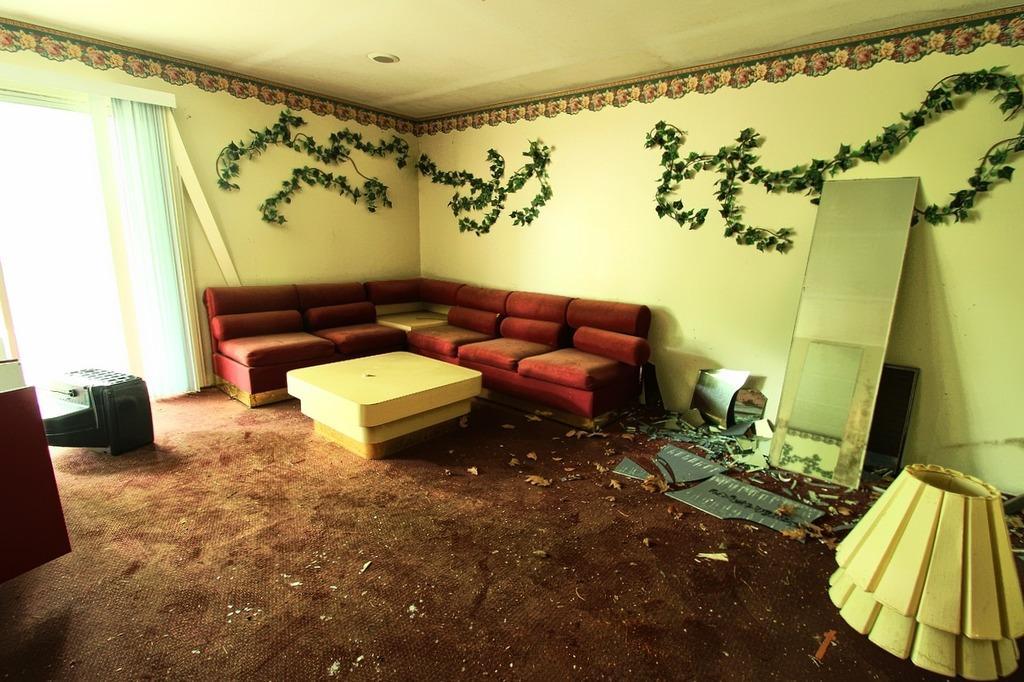In one or two sentences, can you explain what this image depicts? As we can see in the image there is a yellow color wall, a window and red color sofas over here. On the right side there is a lamp. 